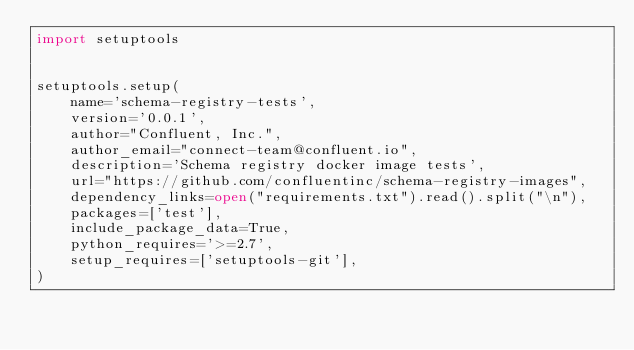<code> <loc_0><loc_0><loc_500><loc_500><_Python_>import setuptools


setuptools.setup(
    name='schema-registry-tests',
    version='0.0.1',
    author="Confluent, Inc.",
    author_email="connect-team@confluent.io",
    description='Schema registry docker image tests',
    url="https://github.com/confluentinc/schema-registry-images",
    dependency_links=open("requirements.txt").read().split("\n"),
    packages=['test'],
    include_package_data=True,
    python_requires='>=2.7',
    setup_requires=['setuptools-git'],
)
</code> 